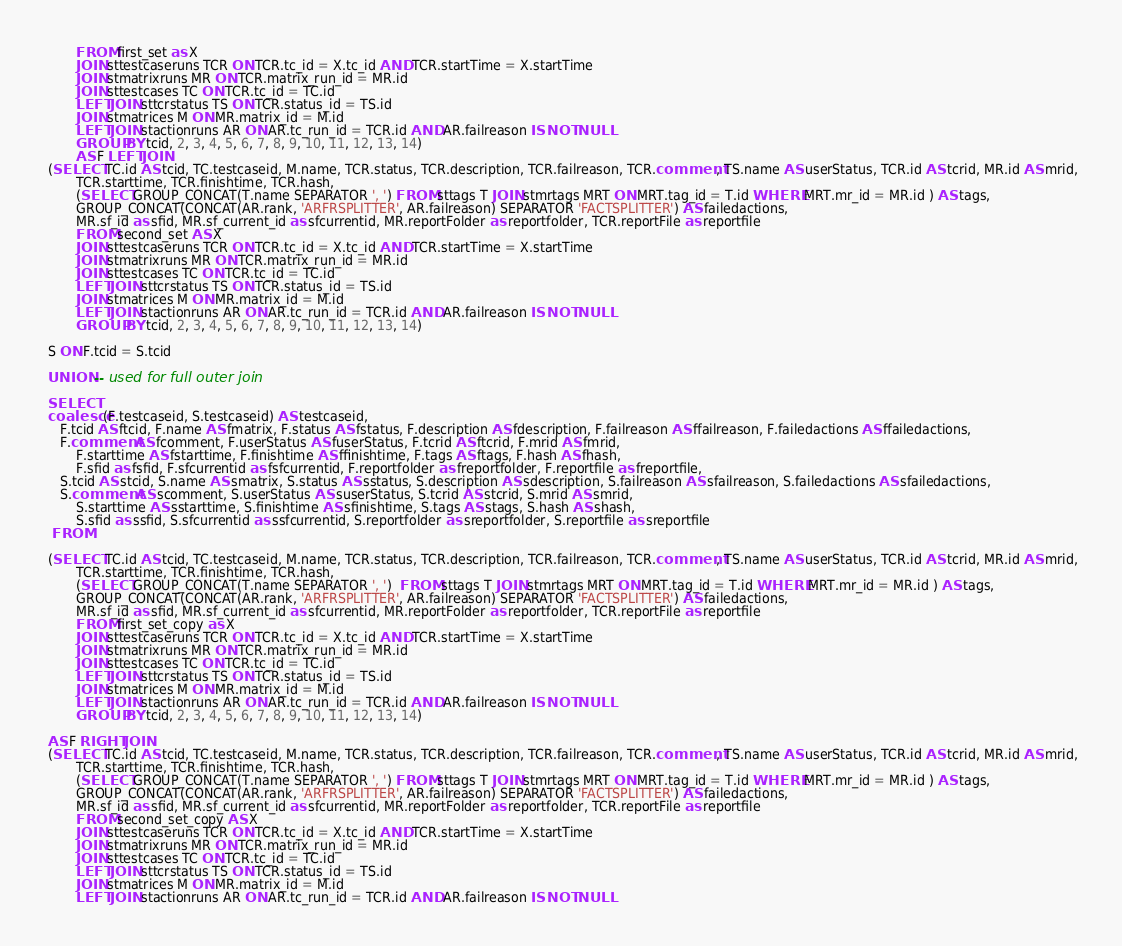Convert code to text. <code><loc_0><loc_0><loc_500><loc_500><_SQL_>        FROM first_set as X
        JOIN sttestcaseruns TCR ON TCR.tc_id = X.tc_id AND TCR.startTime = X.startTime
        JOIN stmatrixruns MR ON TCR.matrix_run_id = MR.id
        JOIN sttestcases TC ON TCR.tc_id = TC.id
        LEFT JOIN sttcrstatus TS ON TCR.status_id = TS.id
        JOIN stmatrices M ON MR.matrix_id = M.id
        LEFT JOIN stactionruns AR ON AR.tc_run_id = TCR.id AND AR.failreason IS NOT NULL
        GROUP BY tcid, 2, 3, 4, 5, 6, 7, 8, 9, 10, 11, 12, 13, 14)
        AS F LEFT JOIN
 (SELECT TC.id AS tcid, TC.testcaseid, M.name, TCR.status, TCR.description, TCR.failreason, TCR.comment, TS.name AS userStatus, TCR.id AS tcrid, MR.id AS mrid,
        TCR.starttime, TCR.finishtime, TCR.hash,
        (SELECT GROUP_CONCAT(T.name SEPARATOR ', ') FROM sttags T JOIN stmrtags MRT ON MRT.tag_id = T.id WHERE MRT.mr_id = MR.id ) AS tags,
        GROUP_CONCAT(CONCAT(AR.rank, 'ARFRSPLITTER', AR.failreason) SEPARATOR 'FACTSPLITTER') AS failedactions,
        MR.sf_id as sfid, MR.sf_current_id as sfcurrentid, MR.reportFolder as reportfolder, TCR.reportFile as reportfile
        FROM second_set AS X
        JOIN sttestcaseruns TCR ON TCR.tc_id = X.tc_id AND TCR.startTime = X.startTime
        JOIN stmatrixruns MR ON TCR.matrix_run_id = MR.id
        JOIN sttestcases TC ON TCR.tc_id = TC.id
        LEFT JOIN sttcrstatus TS ON TCR.status_id = TS.id
        JOIN stmatrices M ON MR.matrix_id = M.id
        LEFT JOIN stactionruns AR ON AR.tc_run_id = TCR.id AND AR.failreason IS NOT NULL
        GROUP BY tcid, 2, 3, 4, 5, 6, 7, 8, 9, 10, 11, 12, 13, 14)

 S ON F.tcid = S.tcid

 UNION -- used for full outer join

 SELECT
 coalesce(F.testcaseid, S.testcaseid) AS testcaseid,
    F.tcid AS ftcid, F.name AS fmatrix, F.status AS fstatus, F.description AS fdescription, F.failreason AS ffailreason, F.failedactions AS ffailedactions,
    F.comment AS fcomment, F.userStatus AS fuserStatus, F.tcrid AS ftcrid, F.mrid AS fmrid,
        F.starttime AS fstarttime, F.finishtime AS ffinishtime, F.tags AS ftags, F.hash AS fhash,
        F.sfid as fsfid, F.sfcurrentid as fsfcurrentid, F.reportfolder as freportfolder, F.reportfile as freportfile,
    S.tcid AS stcid, S.name AS smatrix, S.status AS sstatus, S.description AS sdescription, S.failreason AS sfailreason, S.failedactions AS sfailedactions,
    S.comment AS scomment, S.userStatus AS suserStatus, S.tcrid AS stcrid, S.mrid AS smrid,
        S.starttime AS sstarttime, S.finishtime AS sfinishtime, S.tags AS stags, S.hash AS shash,
        S.sfid as ssfid, S.sfcurrentid as ssfcurrentid, S.reportfolder as sreportfolder, S.reportfile as sreportfile
  FROM

 (SELECT TC.id AS tcid, TC.testcaseid, M.name, TCR.status, TCR.description, TCR.failreason, TCR.comment, TS.name AS userStatus, TCR.id AS tcrid, MR.id AS mrid,
        TCR.starttime, TCR.finishtime, TCR.hash,
        (SELECT GROUP_CONCAT(T.name SEPARATOR ', ')  FROM sttags T JOIN stmrtags MRT ON MRT.tag_id = T.id WHERE MRT.mr_id = MR.id ) AS tags,
        GROUP_CONCAT(CONCAT(AR.rank, 'ARFRSPLITTER', AR.failreason) SEPARATOR 'FACTSPLITTER') AS failedactions,
        MR.sf_id as sfid, MR.sf_current_id as sfcurrentid, MR.reportFolder as reportfolder, TCR.reportFile as reportfile
        FROM first_set_copy as X
        JOIN sttestcaseruns TCR ON TCR.tc_id = X.tc_id AND TCR.startTime = X.startTime
        JOIN stmatrixruns MR ON TCR.matrix_run_id = MR.id
        JOIN sttestcases TC ON TCR.tc_id = TC.id
        LEFT JOIN sttcrstatus TS ON TCR.status_id = TS.id
        JOIN stmatrices M ON MR.matrix_id = M.id
        LEFT JOIN stactionruns AR ON AR.tc_run_id = TCR.id AND AR.failreason IS NOT NULL
        GROUP BY tcid, 2, 3, 4, 5, 6, 7, 8, 9, 10, 11, 12, 13, 14)

 AS F RIGHT JOIN
 (SELECT TC.id AS tcid, TC.testcaseid, M.name, TCR.status, TCR.description, TCR.failreason, TCR.comment, TS.name AS userStatus, TCR.id AS tcrid, MR.id AS mrid,
        TCR.starttime, TCR.finishtime, TCR.hash,
        (SELECT GROUP_CONCAT(T.name SEPARATOR ', ') FROM sttags T JOIN stmrtags MRT ON MRT.tag_id = T.id WHERE MRT.mr_id = MR.id ) AS tags,
        GROUP_CONCAT(CONCAT(AR.rank, 'ARFRSPLITTER', AR.failreason) SEPARATOR 'FACTSPLITTER') AS failedactions,
        MR.sf_id as sfid, MR.sf_current_id as sfcurrentid, MR.reportFolder as reportfolder, TCR.reportFile as reportfile
        FROM second_set_copy AS X
        JOIN sttestcaseruns TCR ON TCR.tc_id = X.tc_id AND TCR.startTime = X.startTime
        JOIN stmatrixruns MR ON TCR.matrix_run_id = MR.id
        JOIN sttestcases TC ON TCR.tc_id = TC.id
        LEFT JOIN sttcrstatus TS ON TCR.status_id = TS.id
        JOIN stmatrices M ON MR.matrix_id = M.id
        LEFT JOIN stactionruns AR ON AR.tc_run_id = TCR.id AND AR.failreason IS NOT NULL</code> 